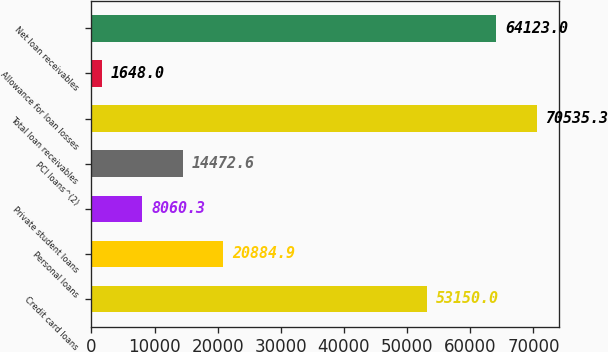Convert chart. <chart><loc_0><loc_0><loc_500><loc_500><bar_chart><fcel>Credit card loans<fcel>Personal loans<fcel>Private student loans<fcel>PCI loans^(2)<fcel>Total loan receivables<fcel>Allowance for loan losses<fcel>Net loan receivables<nl><fcel>53150<fcel>20884.9<fcel>8060.3<fcel>14472.6<fcel>70535.3<fcel>1648<fcel>64123<nl></chart> 